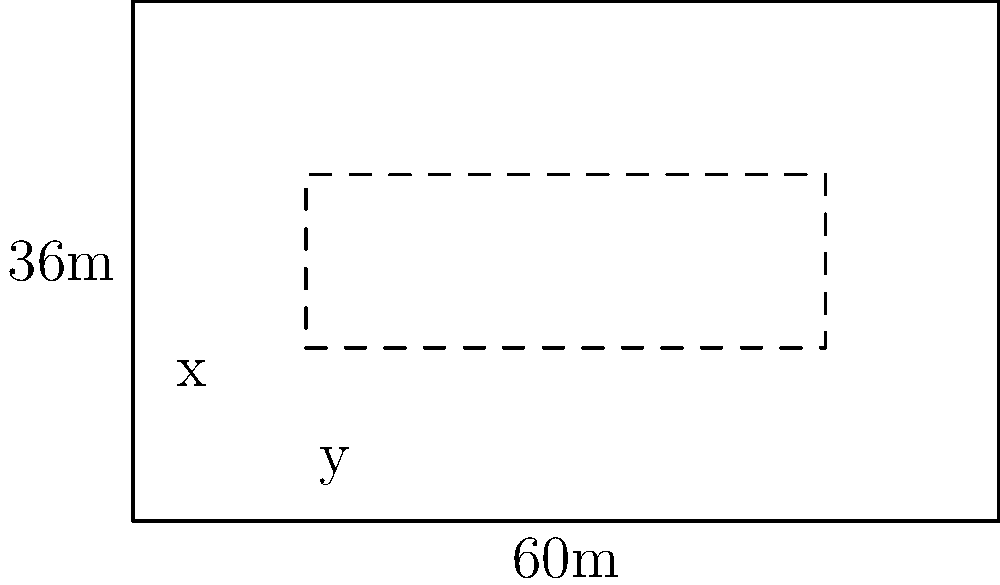An exhibition hall has a rectangular floor plan measuring 60m by 36m. You need to design a booth layout that maximizes the total perimeter available for displays while maintaining a minimum area of 120 square meters for walkways and common spaces. What are the dimensions of the largest possible rectangular booth area that satisfies these conditions? Let's approach this step-by-step:

1) Let the booth dimensions be $x$ meters wide and $y$ meters long.

2) The area of the booth will be $xy$ square meters.

3) The area of the walkways and common spaces will be $(60 \times 36) - xy = 2160 - xy$ square meters.

4) We need this area to be at least 120 square meters:
   $2160 - xy \geq 120$
   $xy \leq 2040$

5) The perimeter of the booth will be $2x + 2y$. We want to maximize this.

6) We can express $y$ in terms of $x$:
   $xy = 2040$
   $y = \frac{2040}{x}$

7) Now, we need to maximize $2x + 2y = 2x + \frac{4080}{x}$

8) To find the maximum, we differentiate and set to zero:
   $\frac{d}{dx}(2x + \frac{4080}{x}) = 2 - \frac{4080}{x^2} = 0$

9) Solving this:
   $2 = \frac{4080}{x^2}$
   $x^2 = 2040$
   $x = \sqrt{2040} = 45.17$

10) Rounding to the nearest meter (as it's unlikely to have fractional meters in booth design):
    $x = 45$ meters

11) Then $y = \frac{2040}{45} = 45.33$, which rounds to 45 meters as well.

Therefore, the optimal booth dimensions are 45m by 45m.
Answer: 45m x 45m 